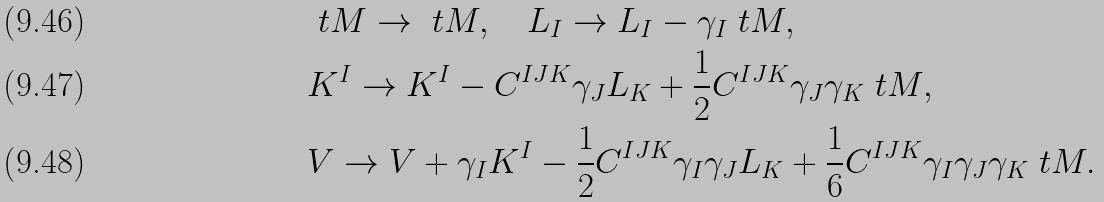<formula> <loc_0><loc_0><loc_500><loc_500>& \ t M \rightarrow \ t M , \quad L _ { I } \rightarrow L _ { I } - \gamma _ { I } \ t M , \\ & K ^ { I } \rightarrow K ^ { I } - C ^ { I J K } \gamma _ { J } L _ { K } + \frac { 1 } { 2 } C ^ { I J K } \gamma _ { J } \gamma _ { K } \ t M , \\ & V \rightarrow V + \gamma _ { I } K ^ { I } - \frac { 1 } { 2 } C ^ { I J K } \gamma _ { I } \gamma _ { J } L _ { K } + \frac { 1 } { 6 } C ^ { I J K } \gamma _ { I } \gamma _ { J } \gamma _ { K } \ t M .</formula> 